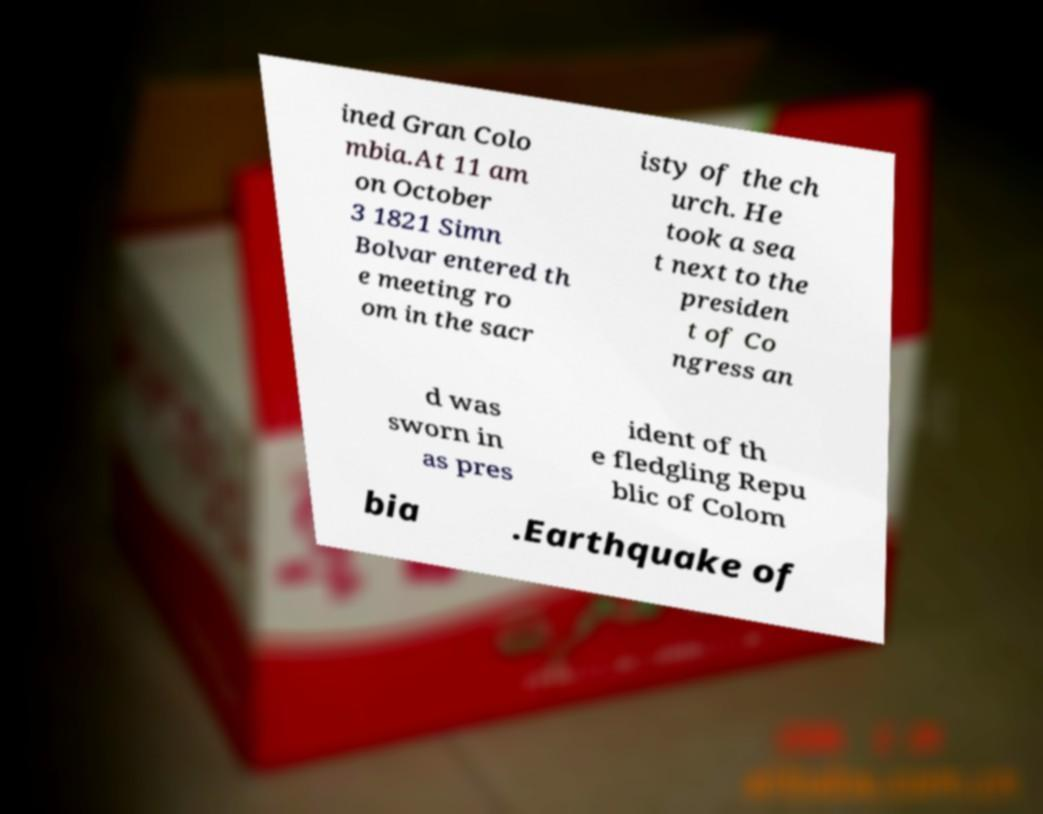There's text embedded in this image that I need extracted. Can you transcribe it verbatim? ined Gran Colo mbia.At 11 am on October 3 1821 Simn Bolvar entered th e meeting ro om in the sacr isty of the ch urch. He took a sea t next to the presiden t of Co ngress an d was sworn in as pres ident of th e fledgling Repu blic of Colom bia .Earthquake of 